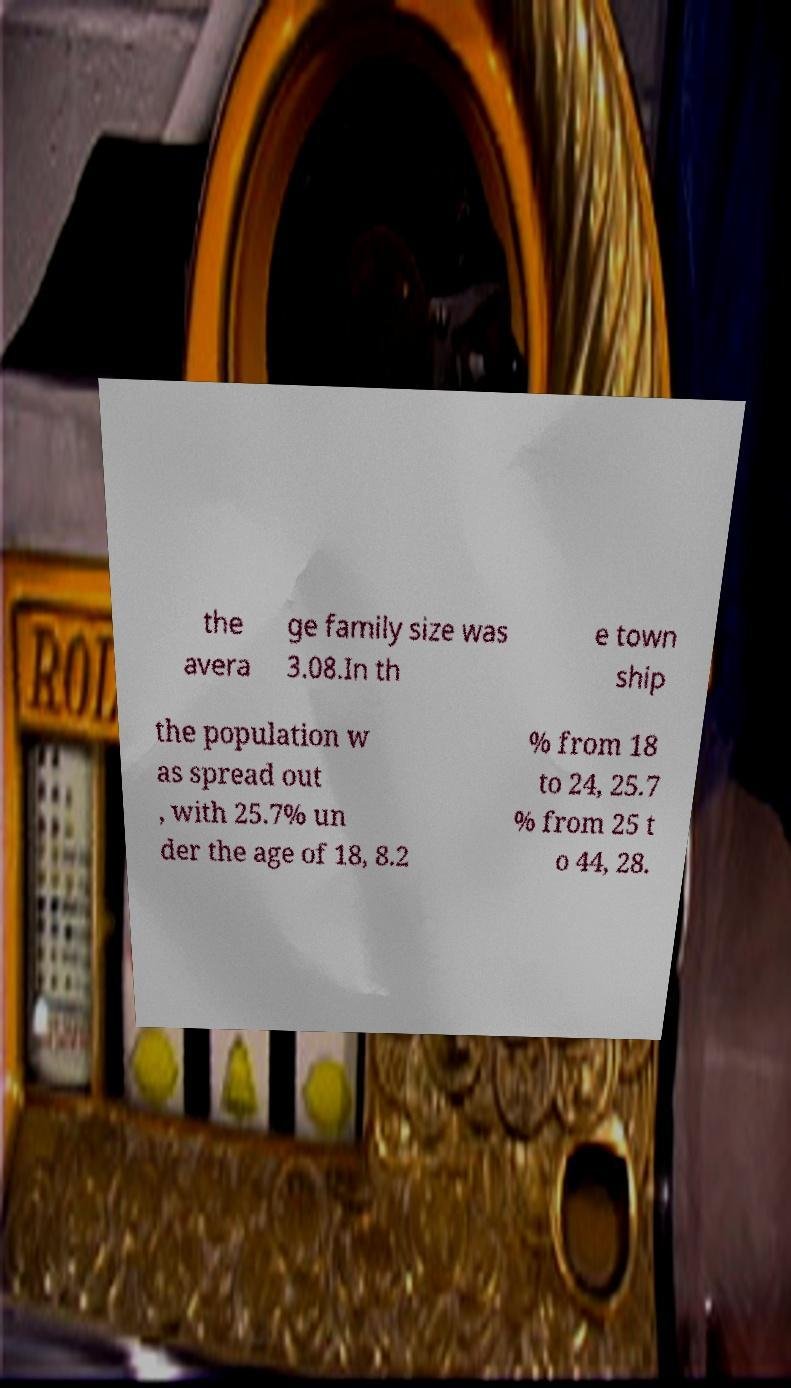Could you assist in decoding the text presented in this image and type it out clearly? the avera ge family size was 3.08.In th e town ship the population w as spread out , with 25.7% un der the age of 18, 8.2 % from 18 to 24, 25.7 % from 25 t o 44, 28. 